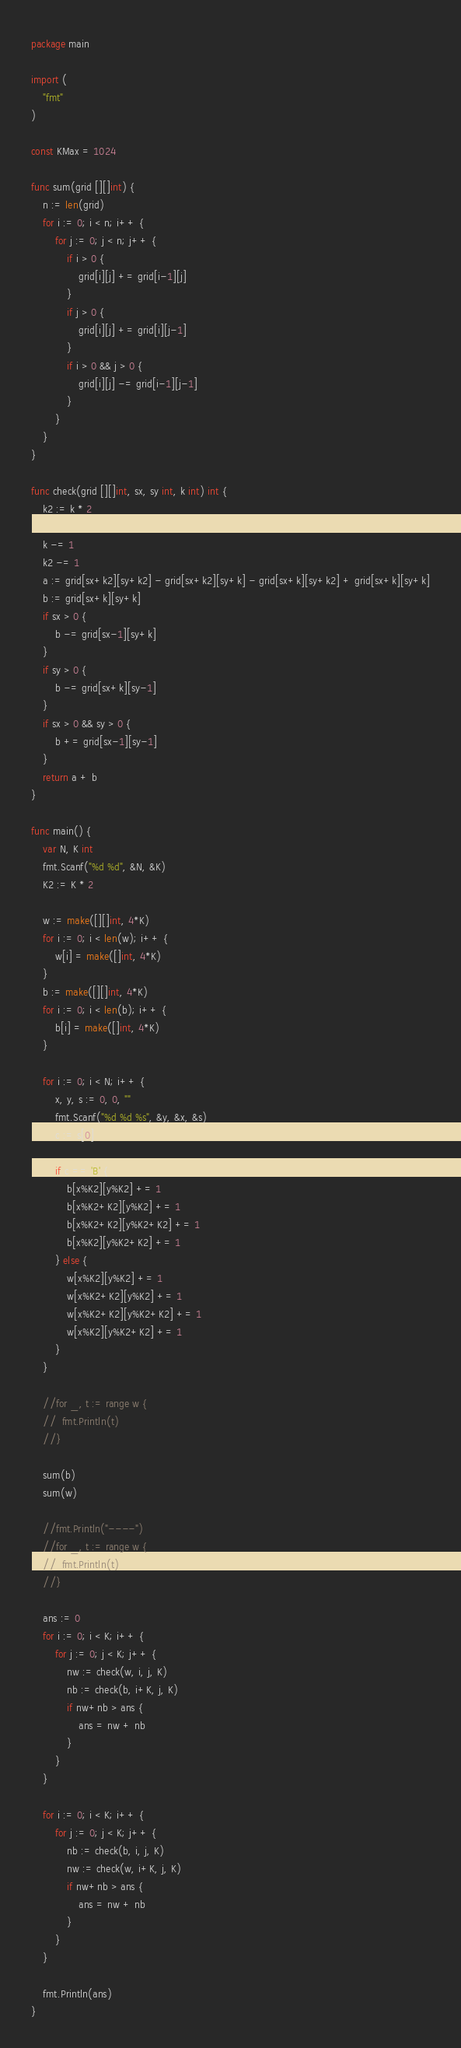Convert code to text. <code><loc_0><loc_0><loc_500><loc_500><_Go_>package main

import (
	"fmt"
)

const KMax = 1024

func sum(grid [][]int) {
	n := len(grid)
	for i := 0; i < n; i++ {
		for j := 0; j < n; j++ {
			if i > 0 {
				grid[i][j] += grid[i-1][j]
			}
			if j > 0 {
				grid[i][j] += grid[i][j-1]
			}
			if i > 0 && j > 0 {
				grid[i][j] -= grid[i-1][j-1]
			}
		}
	}
}

func check(grid [][]int, sx, sy int, k int) int {
	k2 := k * 2

	k -= 1
	k2 -= 1
	a := grid[sx+k2][sy+k2] - grid[sx+k2][sy+k] - grid[sx+k][sy+k2] + grid[sx+k][sy+k]
	b := grid[sx+k][sy+k]
	if sx > 0 {
		b -= grid[sx-1][sy+k]
	}
	if sy > 0 {
		b -= grid[sx+k][sy-1]
	}
	if sx > 0 && sy > 0 {
		b += grid[sx-1][sy-1]
	}
	return a + b
}

func main() {
	var N, K int
	fmt.Scanf("%d %d", &N, &K)
	K2 := K * 2

	w := make([][]int, 4*K)
	for i := 0; i < len(w); i++ {
		w[i] = make([]int, 4*K)
	}
	b := make([][]int, 4*K)
	for i := 0; i < len(b); i++ {
		b[i] = make([]int, 4*K)
	}

	for i := 0; i < N; i++ {
		x, y, s := 0, 0, ""
		fmt.Scanf("%d %d %s", &y, &x, &s)
		c := s[0]

		if c == 'B' {
			b[x%K2][y%K2] += 1
			b[x%K2+K2][y%K2] += 1
			b[x%K2+K2][y%K2+K2] += 1
			b[x%K2][y%K2+K2] += 1
		} else {
			w[x%K2][y%K2] += 1
			w[x%K2+K2][y%K2] += 1
			w[x%K2+K2][y%K2+K2] += 1
			w[x%K2][y%K2+K2] += 1
		}
	}

	//for _, t := range w {
	//	fmt.Println(t)
	//}

	sum(b)
	sum(w)

	//fmt.Println("----")
	//for _, t := range w {
	//	fmt.Println(t)
	//}

	ans := 0
	for i := 0; i < K; i++ {
		for j := 0; j < K; j++ {
			nw := check(w, i, j, K)
			nb := check(b, i+K, j, K)
			if nw+nb > ans {
				ans = nw + nb
			}
		}
	}

	for i := 0; i < K; i++ {
		for j := 0; j < K; j++ {
			nb := check(b, i, j, K)
			nw := check(w, i+K, j, K)
			if nw+nb > ans {
				ans = nw + nb
			}
		}
	}

	fmt.Println(ans)
}
</code> 